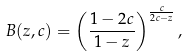<formula> <loc_0><loc_0><loc_500><loc_500>B ( z , c ) = \left ( \frac { 1 - 2 c } { 1 - z } \right ) ^ { \frac { c } { 2 c - z } } ,</formula> 